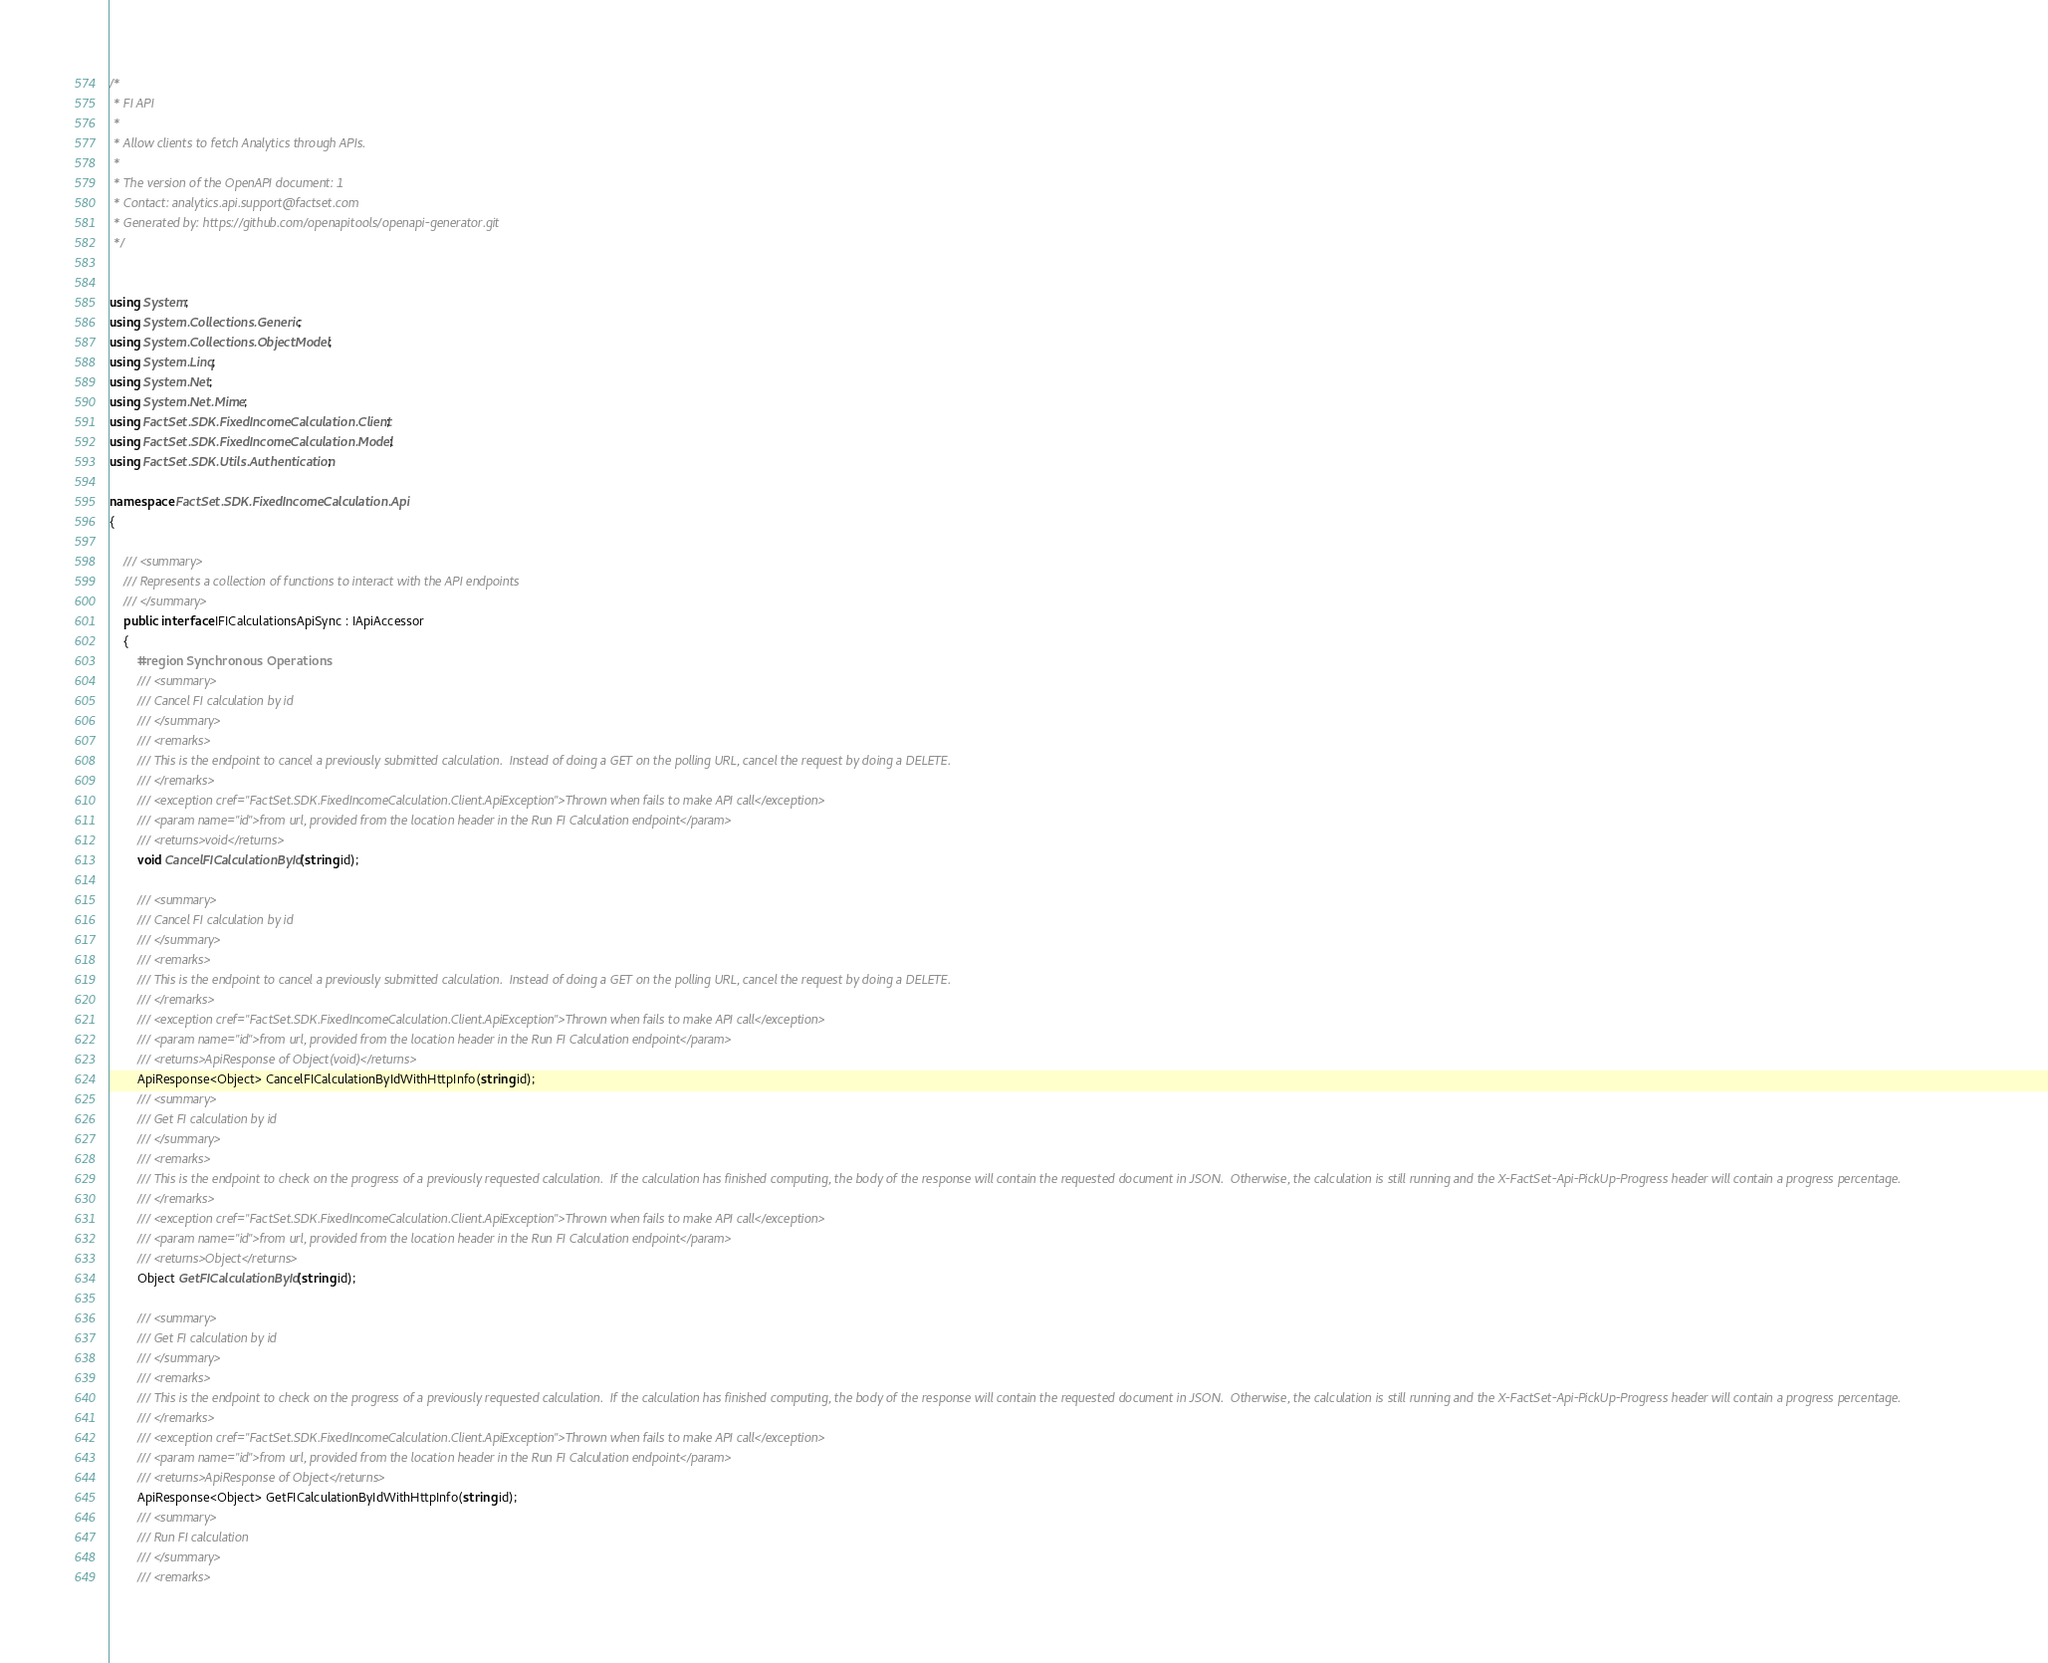Convert code to text. <code><loc_0><loc_0><loc_500><loc_500><_C#_>/*
 * FI API
 *
 * Allow clients to fetch Analytics through APIs.
 *
 * The version of the OpenAPI document: 1
 * Contact: analytics.api.support@factset.com
 * Generated by: https://github.com/openapitools/openapi-generator.git
 */


using System;
using System.Collections.Generic;
using System.Collections.ObjectModel;
using System.Linq;
using System.Net;
using System.Net.Mime;
using FactSet.SDK.FixedIncomeCalculation.Client;
using FactSet.SDK.FixedIncomeCalculation.Model;
using FactSet.SDK.Utils.Authentication;

namespace FactSet.SDK.FixedIncomeCalculation.Api
{

    /// <summary>
    /// Represents a collection of functions to interact with the API endpoints
    /// </summary>
    public interface IFICalculationsApiSync : IApiAccessor
    {
        #region Synchronous Operations
        /// <summary>
        /// Cancel FI calculation by id
        /// </summary>
        /// <remarks>
        /// This is the endpoint to cancel a previously submitted calculation.  Instead of doing a GET on the polling URL, cancel the request by doing a DELETE.
        /// </remarks>
        /// <exception cref="FactSet.SDK.FixedIncomeCalculation.Client.ApiException">Thrown when fails to make API call</exception>
        /// <param name="id">from url, provided from the location header in the Run FI Calculation endpoint</param>
        /// <returns>void</returns>
        void CancelFICalculationById(string id);

        /// <summary>
        /// Cancel FI calculation by id
        /// </summary>
        /// <remarks>
        /// This is the endpoint to cancel a previously submitted calculation.  Instead of doing a GET on the polling URL, cancel the request by doing a DELETE.
        /// </remarks>
        /// <exception cref="FactSet.SDK.FixedIncomeCalculation.Client.ApiException">Thrown when fails to make API call</exception>
        /// <param name="id">from url, provided from the location header in the Run FI Calculation endpoint</param>
        /// <returns>ApiResponse of Object(void)</returns>
        ApiResponse<Object> CancelFICalculationByIdWithHttpInfo(string id);
        /// <summary>
        /// Get FI calculation by id
        /// </summary>
        /// <remarks>
        /// This is the endpoint to check on the progress of a previously requested calculation.  If the calculation has finished computing, the body of the response will contain the requested document in JSON.  Otherwise, the calculation is still running and the X-FactSet-Api-PickUp-Progress header will contain a progress percentage.
        /// </remarks>
        /// <exception cref="FactSet.SDK.FixedIncomeCalculation.Client.ApiException">Thrown when fails to make API call</exception>
        /// <param name="id">from url, provided from the location header in the Run FI Calculation endpoint</param>
        /// <returns>Object</returns>
        Object GetFICalculationById(string id);

        /// <summary>
        /// Get FI calculation by id
        /// </summary>
        /// <remarks>
        /// This is the endpoint to check on the progress of a previously requested calculation.  If the calculation has finished computing, the body of the response will contain the requested document in JSON.  Otherwise, the calculation is still running and the X-FactSet-Api-PickUp-Progress header will contain a progress percentage.
        /// </remarks>
        /// <exception cref="FactSet.SDK.FixedIncomeCalculation.Client.ApiException">Thrown when fails to make API call</exception>
        /// <param name="id">from url, provided from the location header in the Run FI Calculation endpoint</param>
        /// <returns>ApiResponse of Object</returns>
        ApiResponse<Object> GetFICalculationByIdWithHttpInfo(string id);
        /// <summary>
        /// Run FI calculation
        /// </summary>
        /// <remarks></code> 